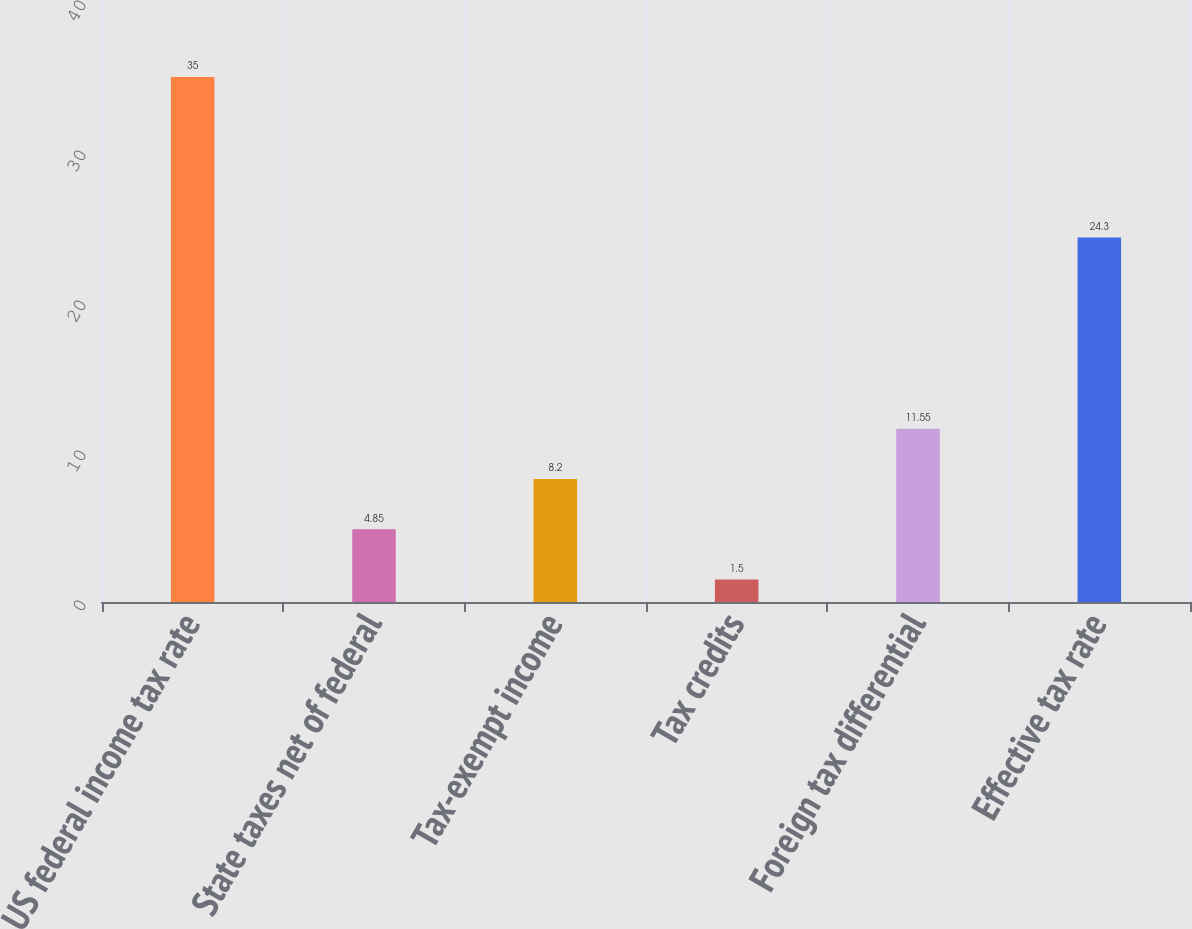<chart> <loc_0><loc_0><loc_500><loc_500><bar_chart><fcel>US federal income tax rate<fcel>State taxes net of federal<fcel>Tax-exempt income<fcel>Tax credits<fcel>Foreign tax differential<fcel>Effective tax rate<nl><fcel>35<fcel>4.85<fcel>8.2<fcel>1.5<fcel>11.55<fcel>24.3<nl></chart> 